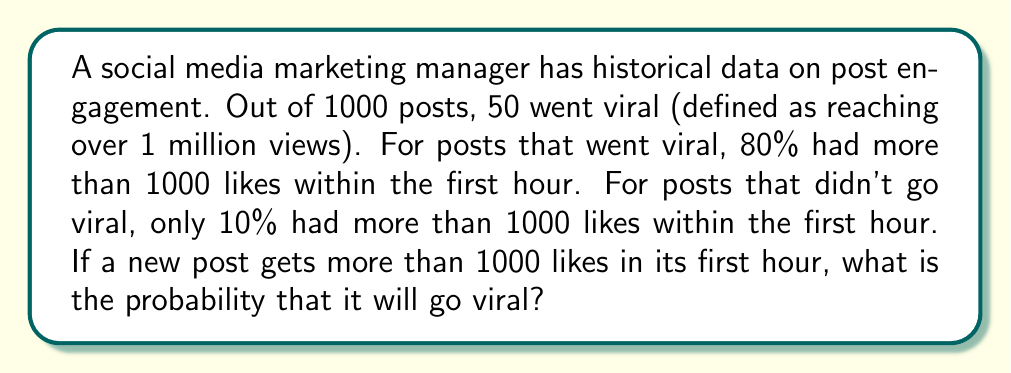Give your solution to this math problem. Let's approach this using Bayes' Theorem:

1) Define events:
   V: Post goes viral
   L: Post gets more than 1000 likes in first hour

2) Given information:
   P(V) = 50/1000 = 0.05 (probability of a post going viral)
   P(L|V) = 0.80 (probability of >1000 likes given that it goes viral)
   P(L|not V) = 0.10 (probability of >1000 likes given that it doesn't go viral)

3) We need to find P(V|L) using Bayes' Theorem:

   $$P(V|L) = \frac{P(L|V) \cdot P(V)}{P(L)}$$

4) Calculate P(L) using the law of total probability:
   $$P(L) = P(L|V) \cdot P(V) + P(L|not V) \cdot P(not V)$$
   $$P(L) = 0.80 \cdot 0.05 + 0.10 \cdot 0.95 = 0.04 + 0.095 = 0.135$$

5) Now apply Bayes' Theorem:
   $$P(V|L) = \frac{0.80 \cdot 0.05}{0.135} = \frac{0.04}{0.135} \approx 0.2963$$

Therefore, the probability that the post will go viral, given that it has more than 1000 likes in the first hour, is approximately 0.2963 or 29.63%.
Answer: 0.2963 